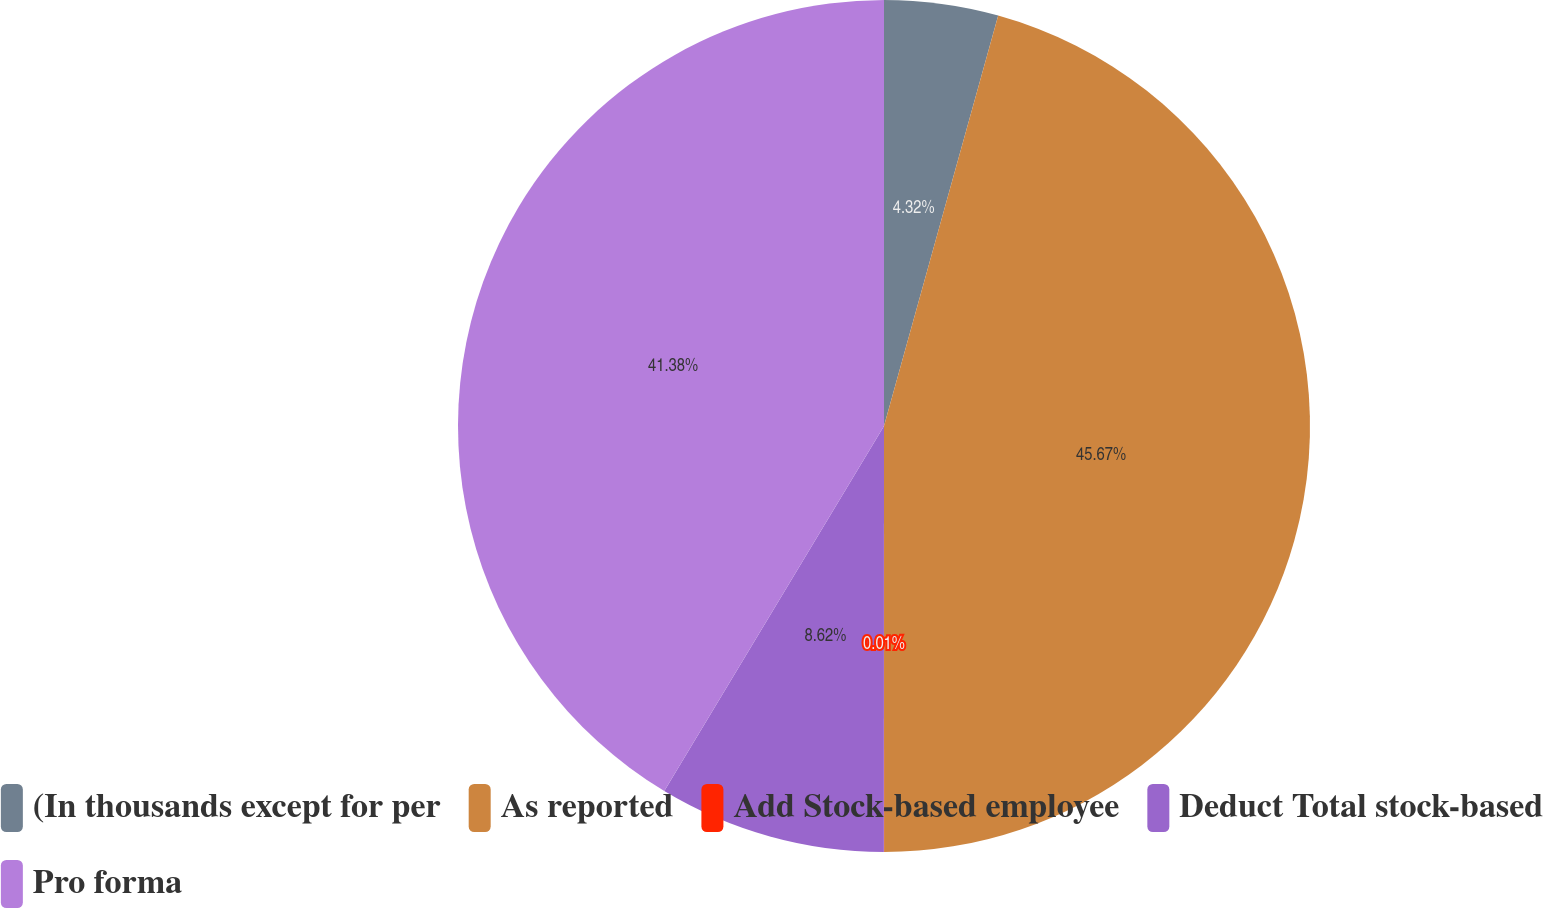Convert chart. <chart><loc_0><loc_0><loc_500><loc_500><pie_chart><fcel>(In thousands except for per<fcel>As reported<fcel>Add Stock-based employee<fcel>Deduct Total stock-based<fcel>Pro forma<nl><fcel>4.32%<fcel>45.68%<fcel>0.01%<fcel>8.62%<fcel>41.38%<nl></chart> 